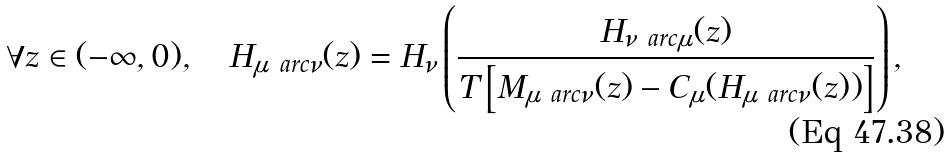Convert formula to latex. <formula><loc_0><loc_0><loc_500><loc_500>\forall z \in ( - \infty , 0 ) , \quad H _ { \mu \ a r c \nu } ( z ) = H _ { \nu } \left ( \frac { H _ { \nu \ a r c \mu } ( z ) } { T \left [ M _ { \mu \ a r c \nu } ( z ) - C _ { \mu } ( H _ { \mu \ a r c \nu } ( z ) ) \right ] } \right ) ,</formula> 